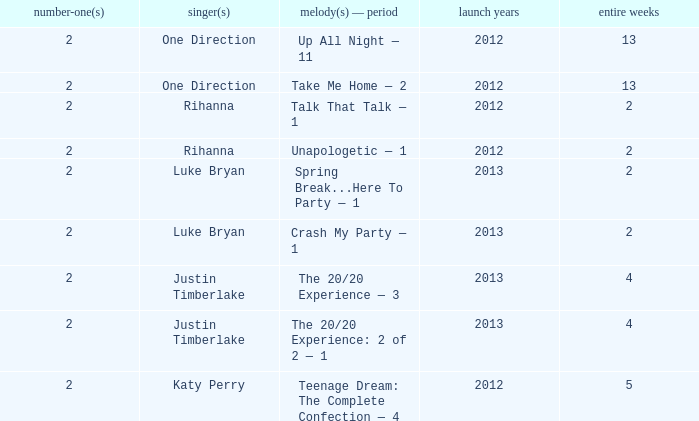What is the title of every song, and how many weeks was each song at #1 for Rihanna in 2012? Talk That Talk — 1, Unapologetic — 1. 